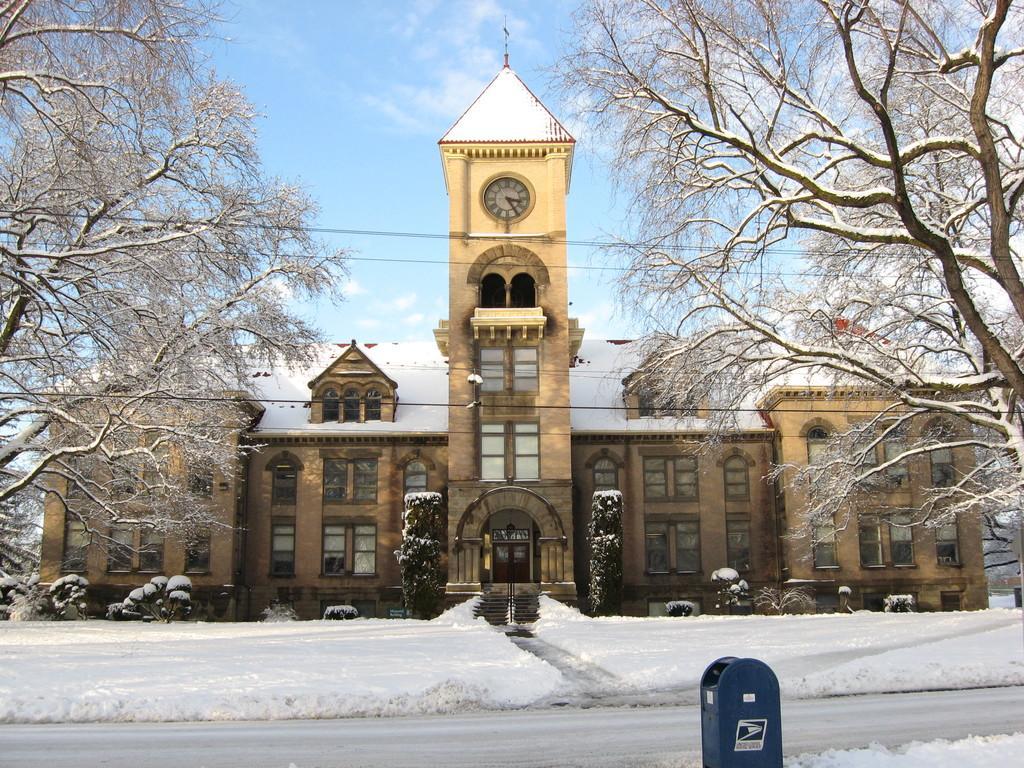Could you give a brief overview of what you see in this image? In this image we can see the road covered with snow, we can see the letter box, trees, wires, plants, house with a clock in the center and the cloudy sky in the background. 